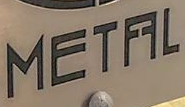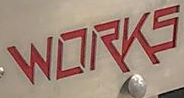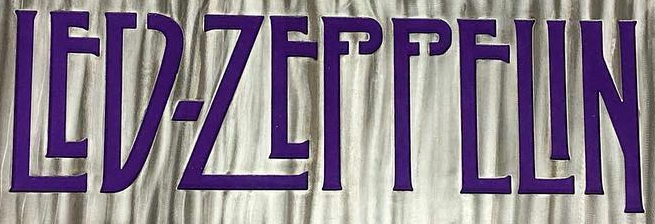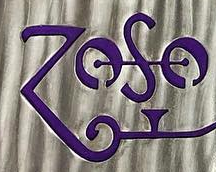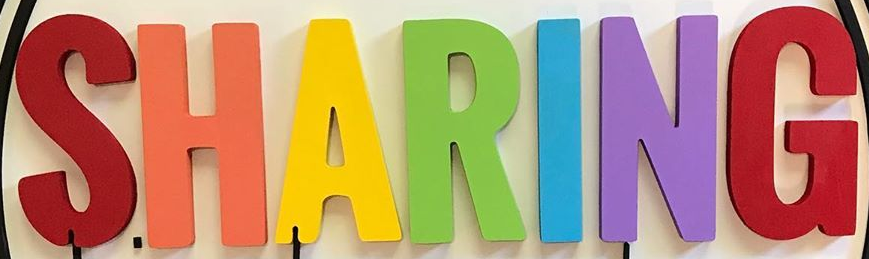What words can you see in these images in sequence, separated by a semicolon? METFFL; WORKS; LED-ZEPPELIN; ZOSO; SHARING 